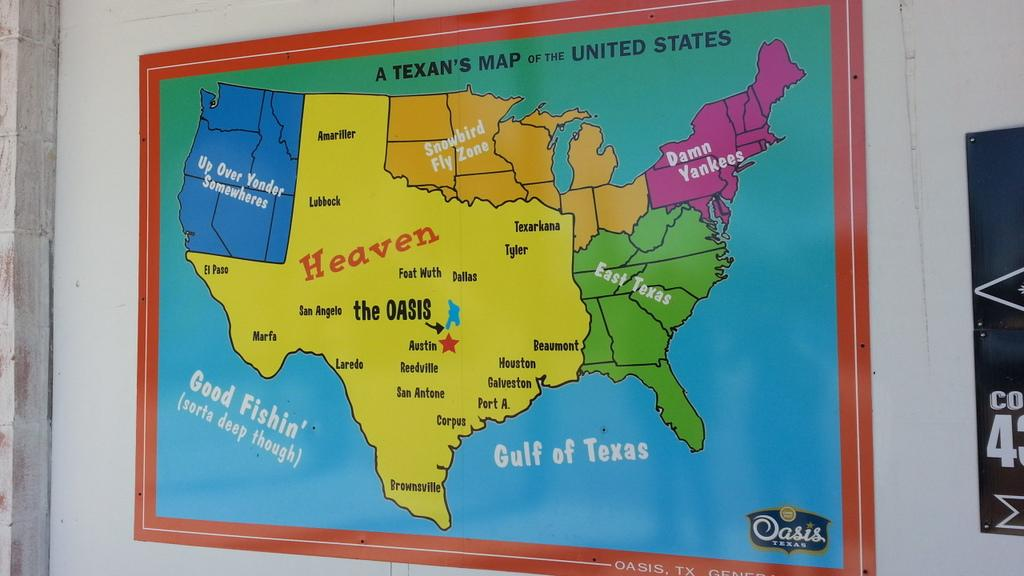What is depicted on the map in the image? The map in the image is of the United States. Where is the map located in the image? The map is attached to a wall. What is the color of the wall the map is attached to? The wall is white in color. What letter is the fireman writing on the map in the image? There is no fireman or letter-writing activity present in the image; it only features a map of the United States attached to a white wall. 